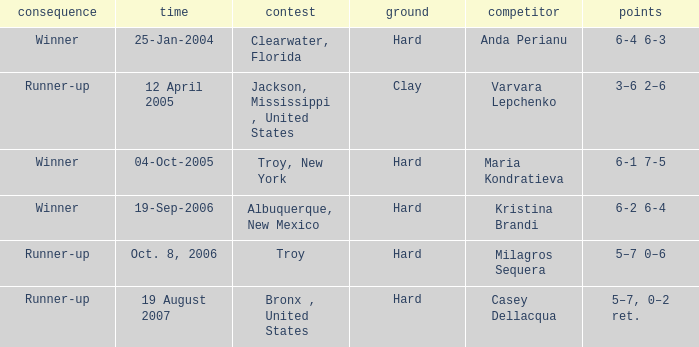What is the final score of the tournament played in Clearwater, Florida? 6-4 6-3. 